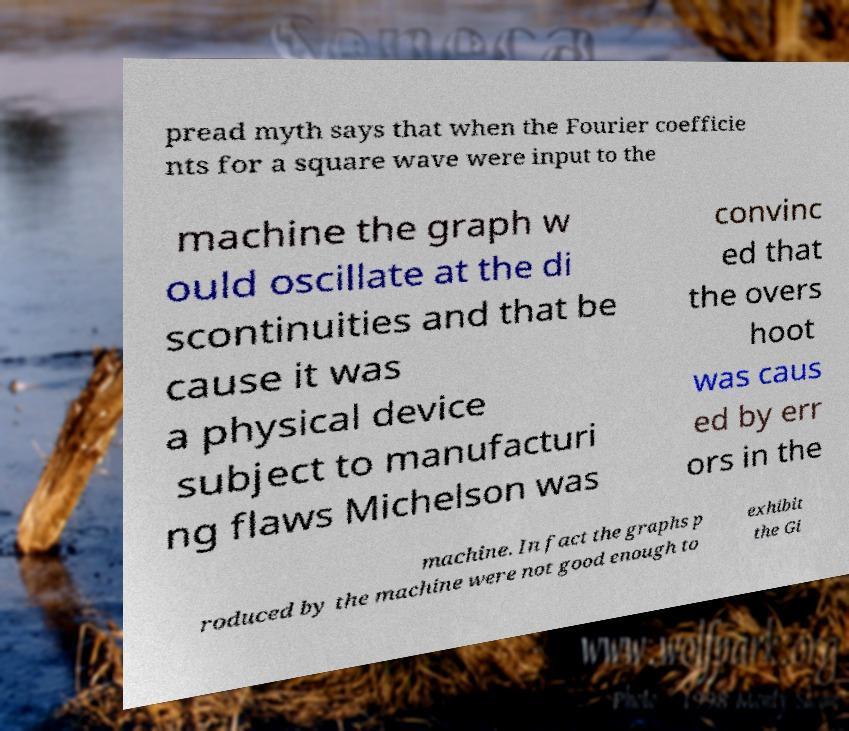There's text embedded in this image that I need extracted. Can you transcribe it verbatim? pread myth says that when the Fourier coefficie nts for a square wave were input to the machine the graph w ould oscillate at the di scontinuities and that be cause it was a physical device subject to manufacturi ng flaws Michelson was convinc ed that the overs hoot was caus ed by err ors in the machine. In fact the graphs p roduced by the machine were not good enough to exhibit the Gi 